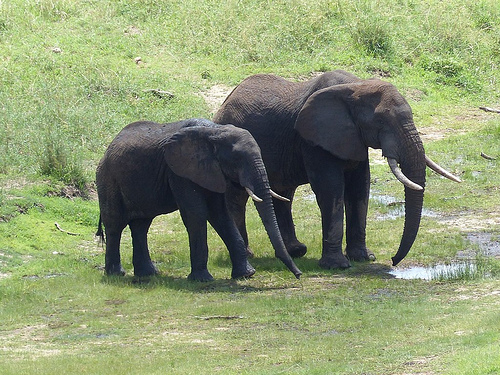How does the larger elephant's posture contribute to its interaction with the environment? The larger elephant's posture suggests it is actively engaging with its environment, perhaps looking for food or water. Its stance appears relaxed yet alert, indicative of an animal that is accustomed to and comfortable in its surroundings. This interaction highlights the elephant's role as a forager and its need to navigate and utilize the resources of its habitat efficiently. What might be the significance of the puddle in their daily life? The puddle might hold significant importance in their daily life as a source of hydration. Elephants need large amounts of water daily, and such puddles provide not just drinking water but also a place to cool down and play. Additionally, wallowing in mud helps protect their sensitive skin from insects and the harsh sun. What stories could the ground tell after days and nights of the elephant's visit? The ground could tell tales of their footprints marking their paths to and from the water sources, the signs of playful elephant baths, and the gentle grazing spots. At night, the ground might speak of rest and repose, lullabies of grass rustling in the evening breezes, and perhaps the communal sounds of a herd bonding and thriving together. If you could ask the smaller elephant about its first memory, what would you inquire, and what might its response be? I would ask the smaller elephant, 'What is your first vivid memory of adventure in the wild?' Its response might be, 'I remember following closely behind my mother, feeling curious excitement as we crossed the bustling savanna. The smells of fresh grass, the call of distant birds, and the comfort of my family's presence filled me with wonder and a sense of belonging.' 